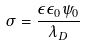Convert formula to latex. <formula><loc_0><loc_0><loc_500><loc_500>\sigma = \frac { \epsilon \epsilon _ { 0 } \psi _ { 0 } } { \lambda _ { D } }</formula> 